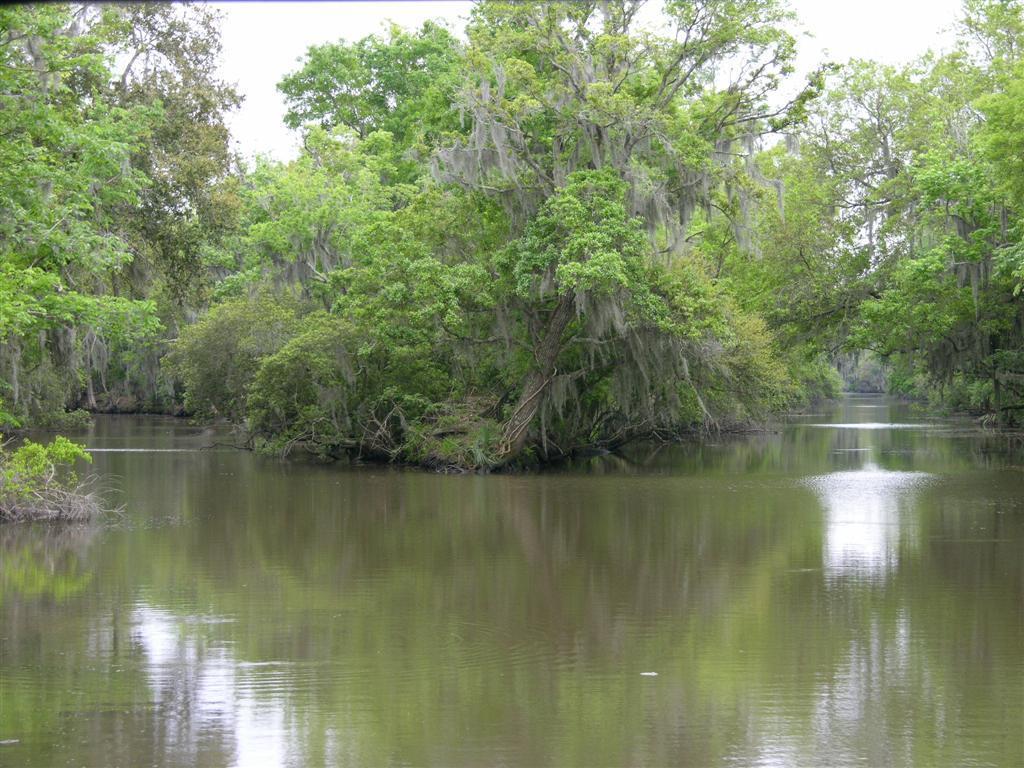Could you give a brief overview of what you see in this image? In the foreground of the picture there is water. In the background there are trees and water. Sky is cloudy. 